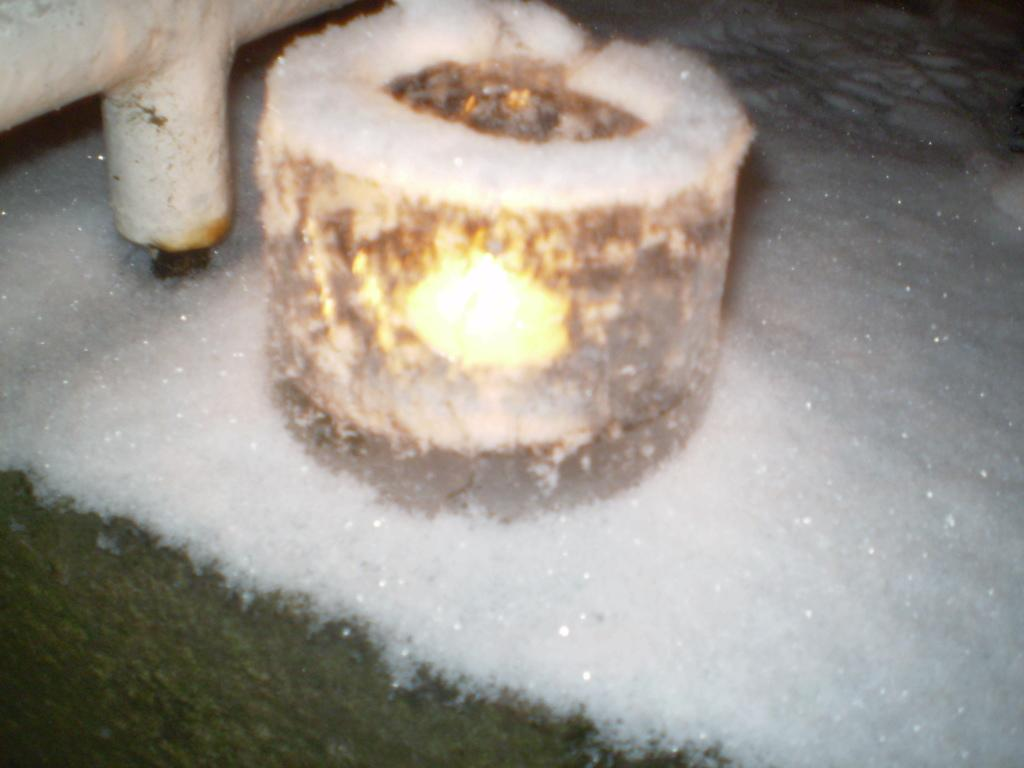What is the source of light in the image? There is a candle light in the image. What type of weather condition is depicted in the image? There is snow visible in the image. Can you describe any architectural features in the image? There might be a pipe in the top left corner of the image. What event is the fireman attending in the image? There is no fireman or event present in the image. In which direction is the north located in the image? The concept of direction, such as north, is not relevant to the image, as it does not contain any geographical or navigational elements. 